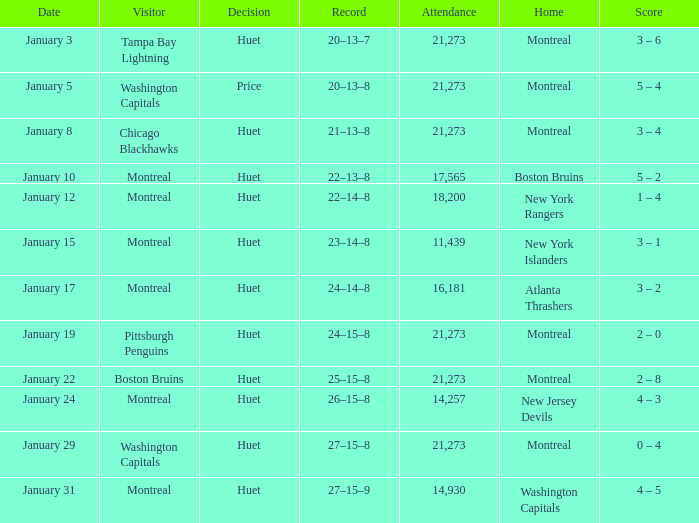What was the date of the game that had a score of 3 – 1? January 15. Can you parse all the data within this table? {'header': ['Date', 'Visitor', 'Decision', 'Record', 'Attendance', 'Home', 'Score'], 'rows': [['January 3', 'Tampa Bay Lightning', 'Huet', '20–13–7', '21,273', 'Montreal', '3 – 6'], ['January 5', 'Washington Capitals', 'Price', '20–13–8', '21,273', 'Montreal', '5 – 4'], ['January 8', 'Chicago Blackhawks', 'Huet', '21–13–8', '21,273', 'Montreal', '3 – 4'], ['January 10', 'Montreal', 'Huet', '22–13–8', '17,565', 'Boston Bruins', '5 – 2'], ['January 12', 'Montreal', 'Huet', '22–14–8', '18,200', 'New York Rangers', '1 – 4'], ['January 15', 'Montreal', 'Huet', '23–14–8', '11,439', 'New York Islanders', '3 – 1'], ['January 17', 'Montreal', 'Huet', '24–14–8', '16,181', 'Atlanta Thrashers', '3 – 2'], ['January 19', 'Pittsburgh Penguins', 'Huet', '24–15–8', '21,273', 'Montreal', '2 – 0'], ['January 22', 'Boston Bruins', 'Huet', '25–15–8', '21,273', 'Montreal', '2 – 8'], ['January 24', 'Montreal', 'Huet', '26–15–8', '14,257', 'New Jersey Devils', '4 – 3'], ['January 29', 'Washington Capitals', 'Huet', '27–15–8', '21,273', 'Montreal', '0 – 4'], ['January 31', 'Montreal', 'Huet', '27–15–9', '14,930', 'Washington Capitals', '4 – 5']]} 